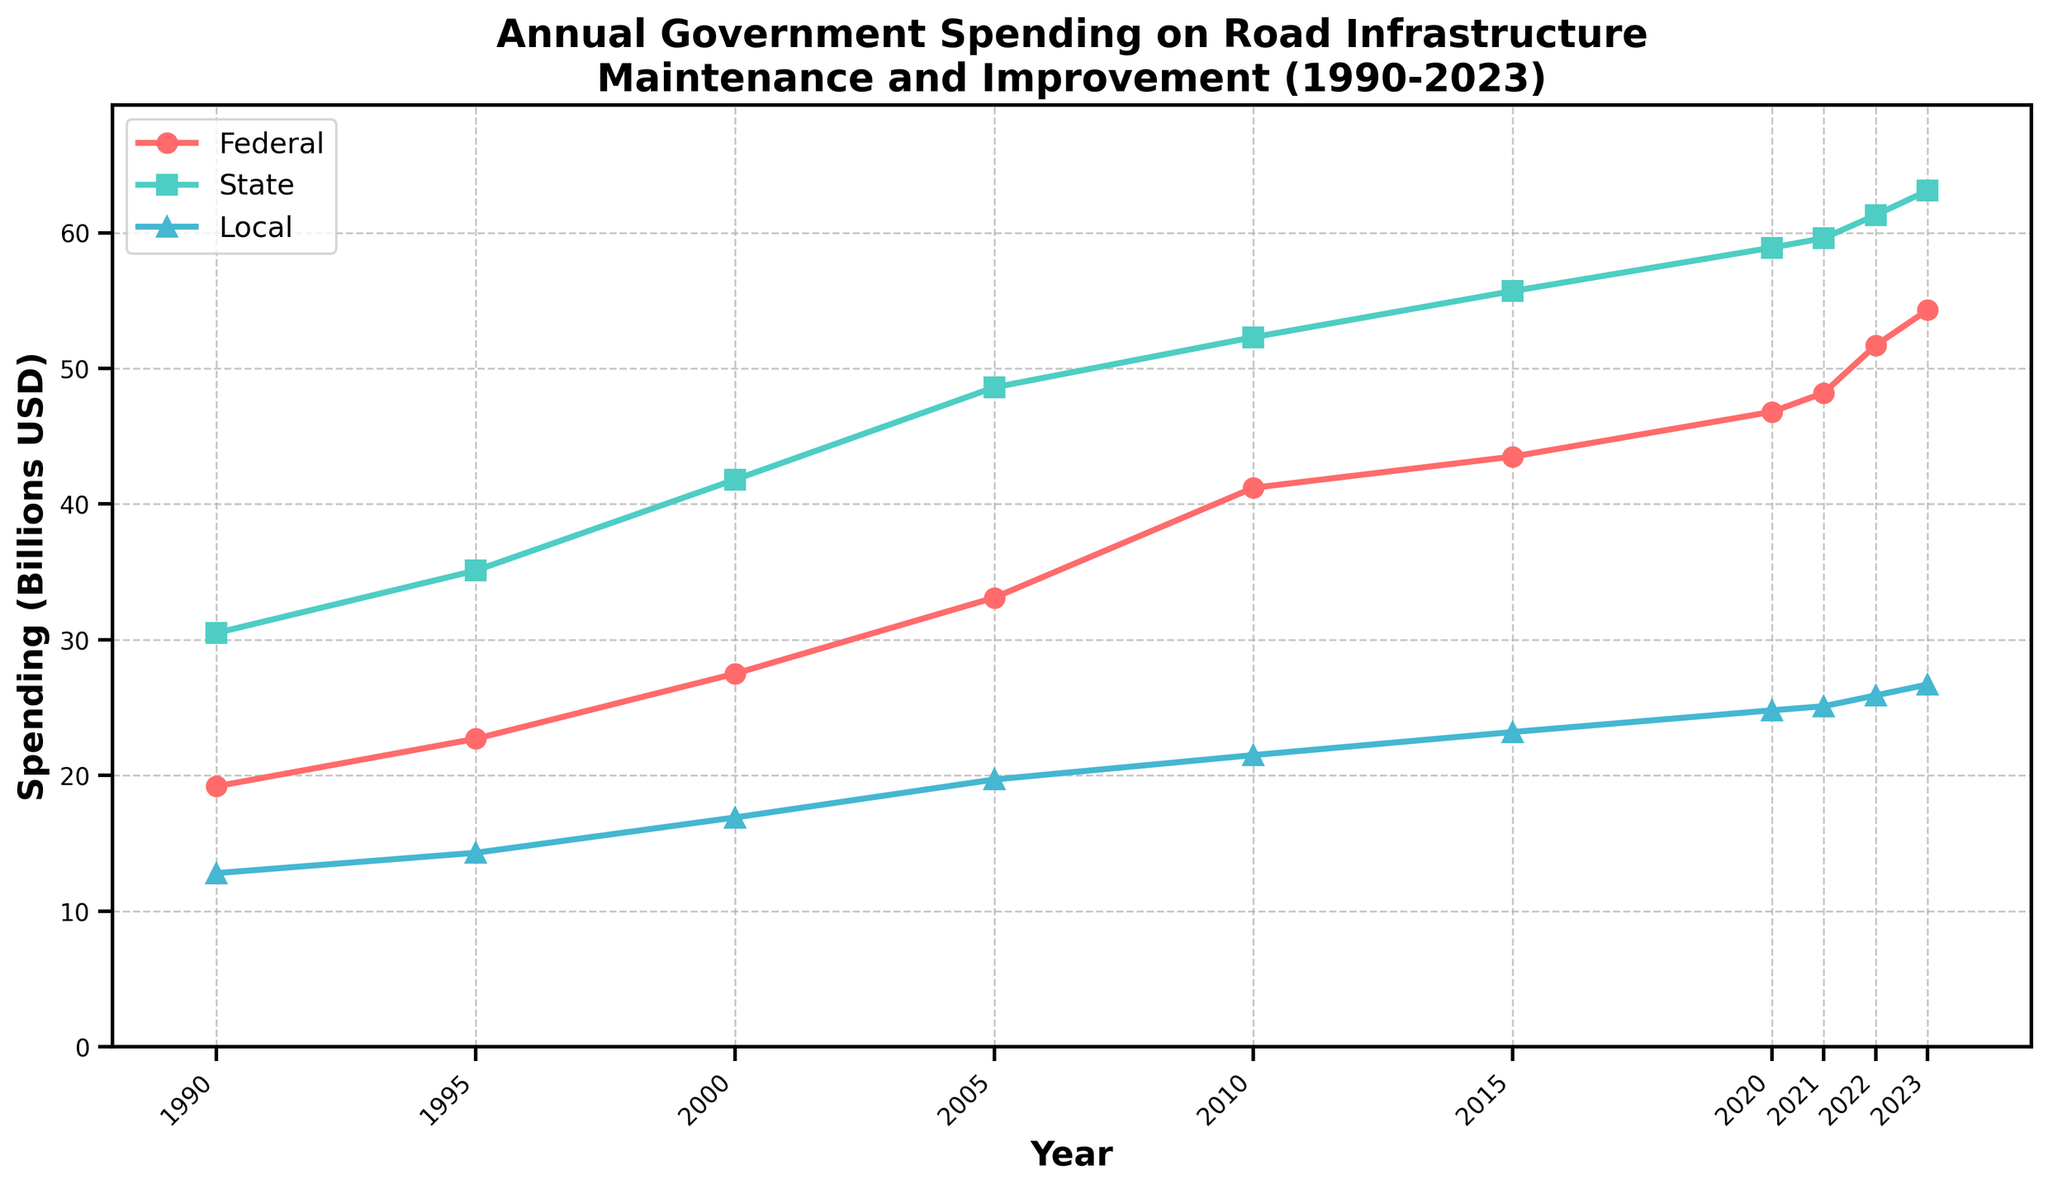What's the total government spending on road infrastructure in 2023? To find the total spending for 2023, we sum the federal, state, and local spending values for that year. According to the data: 54.3 (Federal) + 63.1 (State) + 26.7 (Local) = 144.1 billion USD.
Answer: 144.1 billion USD Which year saw the highest federal spending? By examining the line for federal spending (red line), the highest point is at the end in 2023. According to the data, the federal spending in 2023 is 54.3 billion USD.
Answer: 2023 Did state spending ever decrease from one year to the next? By inspecting the green line representing state spending, we see that it continuously increases from 1990 to 2023 without any drop.
Answer: No How does local spending in 2010 compare to federal spending in 2000? The local spending in 2010 is given as 21.5 billion USD from the data, while the federal spending in 2000 is 27.5 billion USD. Therefore, local spending in 2010 is lower than federal spending in 2000.
Answer: Lower What has been the average annual increase in state spending from 1990 to 2023? To find the average annual increase, we calculate the total increase from 1990 (30.5) to 2023 (63.1) and divide by the number of years, which is 2023-1990 = 33 years. Total increase = 63.1 - 30.5 = 32.6 billion USD. Annual average increase = 32.6 / 33 ≈ 0.988 billion USD.
Answer: Approx. 0.99 billion USD In which year did federal spending surpass 30 billion USD? By examining the federal spending (red line), it surpasses 30 billion USD between 1995 and 2000. According to the data, it happens in 2000 when federal spending is 27.5 billion USD in 1995 and 33.1 billion USD in 2000.
Answer: 2000 Which type of spending had the highest growth rate from 2010 to 2020? By calculating the growth rates:
- Federal spending: (46.8 - 41.2) / 41.2 ≈ 0.136 (13.6%)
- State spending: (58.9 - 52.3) / 52.3 ≈ 0.126 (12.6%)
- Local spending: (24.8 - 21.5) / 21.5 ≈ 0.153 (15.3%)
Local spending had the highest growth rate of approximately 15.3%.
Answer: Local In which year did local spending first exceed 20 billion USD? From the data, local spending first exceeded 20 billion USD in 2005 when it reached 19.7 billion USD and then 21.5 billion USD in 2010. Therefore, 2010 is the first year local spending exceeded 20 billion USD.
Answer: 2010 How much more was state spending than federal spending in 2023? The state spending in 2023 is 63.1 billion USD, and the federal spending is 54.3 billion USD. The difference is 63.1 - 54.3 = 8.8 billion USD.
Answer: 8.8 billion USD Compare the trend of local spending to state spending from 1990 to 2023. From the figure, while both state (green line) and local (blue line) spending show an upward trend, the increase in state spending is consistently much higher, as indicated by the higher starting and ending values compared to local spending.
Answer: State spending increased more 